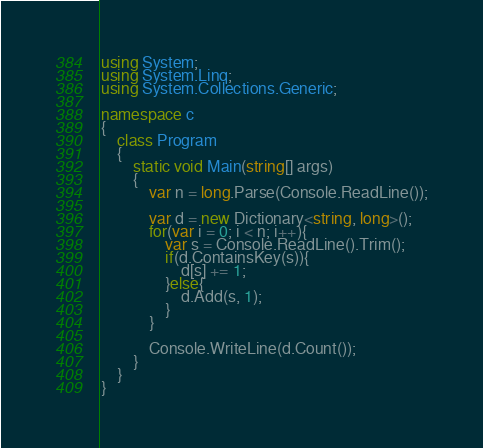<code> <loc_0><loc_0><loc_500><loc_500><_C#_>using System;
using System.Linq;
using System.Collections.Generic;

namespace c
{
    class Program
    {
        static void Main(string[] args)
        {
            var n = long.Parse(Console.ReadLine());

            var d = new Dictionary<string, long>();
            for(var i = 0; i < n; i++){
                var s = Console.ReadLine().Trim();
                if(d.ContainsKey(s)){
                    d[s] += 1;
                }else{
                    d.Add(s, 1);
                }
            }

            Console.WriteLine(d.Count());
        }
    }
}
</code> 